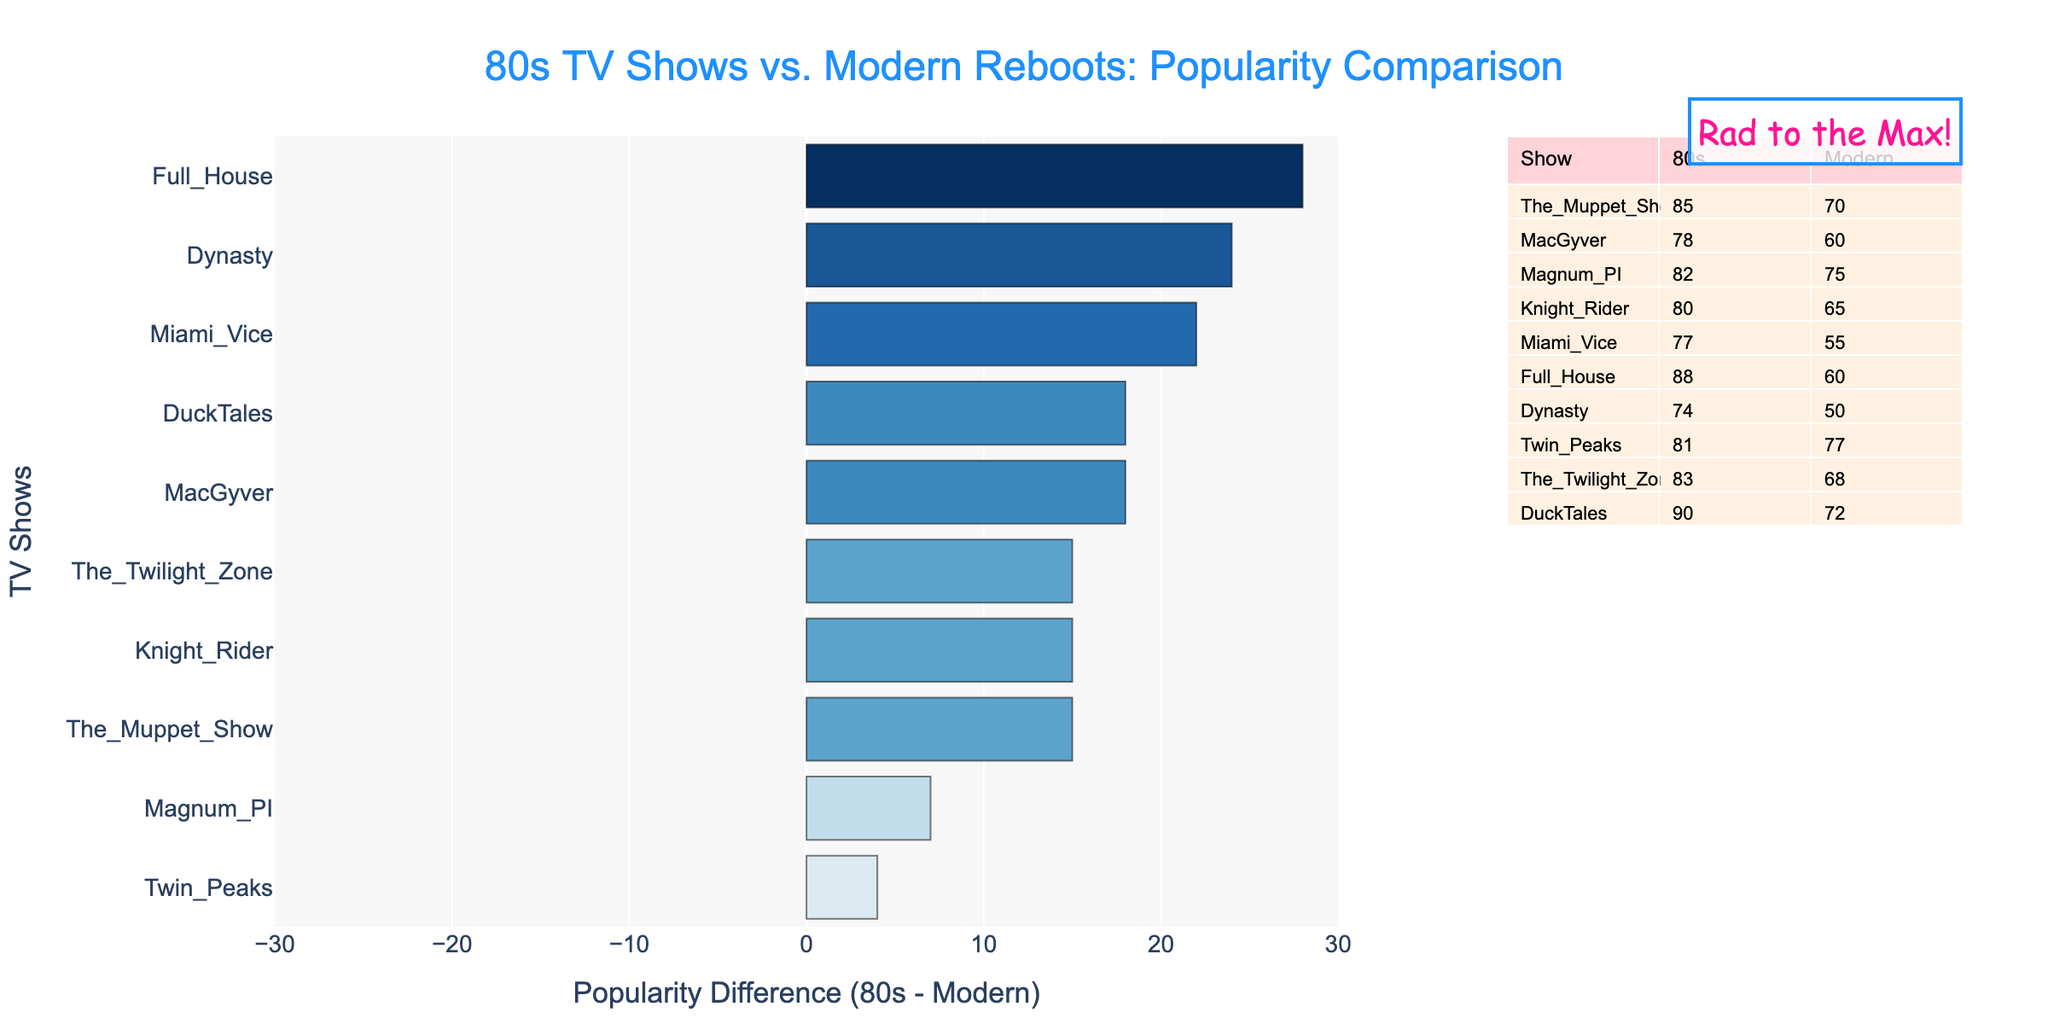Which show has the largest difference in popularity between the 80s and its modern reboot? To find the show with the largest difference in popularity, look for the bar with the greatest length on the chart. Upon inspecting, "Full House" shows the largest difference.
Answer: Full House What are the top three most popular 80s shows based on the chart? To determine the top three most popular 80s shows, refer to the table and identify the highest popularity scores from the 80s column. The top three are "DuckTales" (90), "Full House" (88), and "The Muppet Show" (85).
Answer: DuckTales, Full House, The Muppet Show Which show has the closest popularity between its 80s version and its modern reboot? To find the show with the smallest difference in popularity, look for the shortest bar in the chart. "Twin Peaks" has the smallest difference.
Answer: Twin Peaks What is the combined total popularity of "Magnum PI" for both the 80s and its modern reboot? To find the combined total popularity, sum the popularity of "Magnum PI" in the 80s (82) and its modern reboot (75). 82 + 75 = 157
Answer: 157 Which rebooted show has the lowest popularity, and what is its 80s equivalent's popularity? Based on the table, the show with the lowest modern reboot popularity is "Dynasty" with a score of 50. Its 80s equivalent's popularity is 74.
Answer: Dynasty, 74 Is the popularity of the modern reboot of "DuckTales" greater or less than the 80s version of "The Muppet Show"? Compare the popularity of the "DuckTales" reboot (72) with the 80s version of "The Muppet Show" (85). 72 is less than 85.
Answer: Less What is the average difference in popularity between the 80s shows and their modern reboots? To calculate the average difference, sum all the differences and divide by the number of shows. Differences: 15, 18, 7, 15, 22, 28, 24, 4, 15, 18. Sum = 166. Average = 166/10 = 16.6
Answer: 16.6 Which show has a higher popularity in its modern reboot than in the 80s? To find which show has a higher popularity in its modern reboot, look for any positive values in the difference. Only "Twin Peaks" has a higher popularity in its modern reboot.
Answer: Twin Peaks What color represents the largest negative difference in popularity on the chart? The chart uses a colorscale, with negative differences likely represented in blue tones. The largest negative difference, represented by "Full House," is in blue.
Answer: Blue 